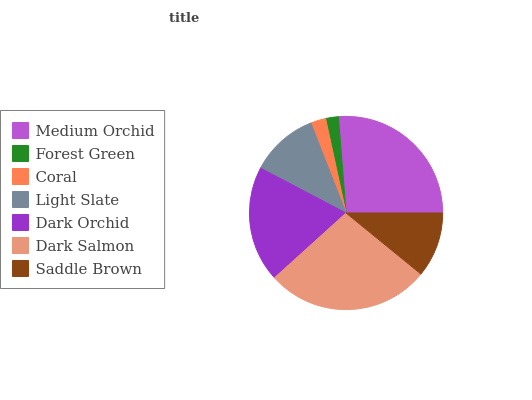Is Forest Green the minimum?
Answer yes or no. Yes. Is Dark Salmon the maximum?
Answer yes or no. Yes. Is Coral the minimum?
Answer yes or no. No. Is Coral the maximum?
Answer yes or no. No. Is Coral greater than Forest Green?
Answer yes or no. Yes. Is Forest Green less than Coral?
Answer yes or no. Yes. Is Forest Green greater than Coral?
Answer yes or no. No. Is Coral less than Forest Green?
Answer yes or no. No. Is Light Slate the high median?
Answer yes or no. Yes. Is Light Slate the low median?
Answer yes or no. Yes. Is Medium Orchid the high median?
Answer yes or no. No. Is Forest Green the low median?
Answer yes or no. No. 